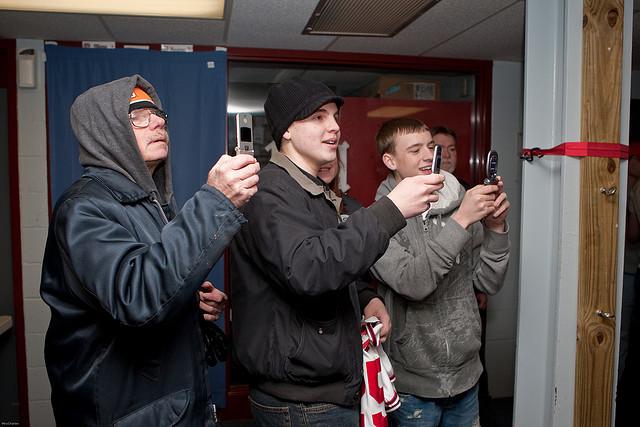What color are the phones?
Quick response, please. Silver. How many people are shown?
Short answer required. 5. What are these people holding up?
Answer briefly. Cell phones. What does the website say?
Write a very short answer. Nothing. 